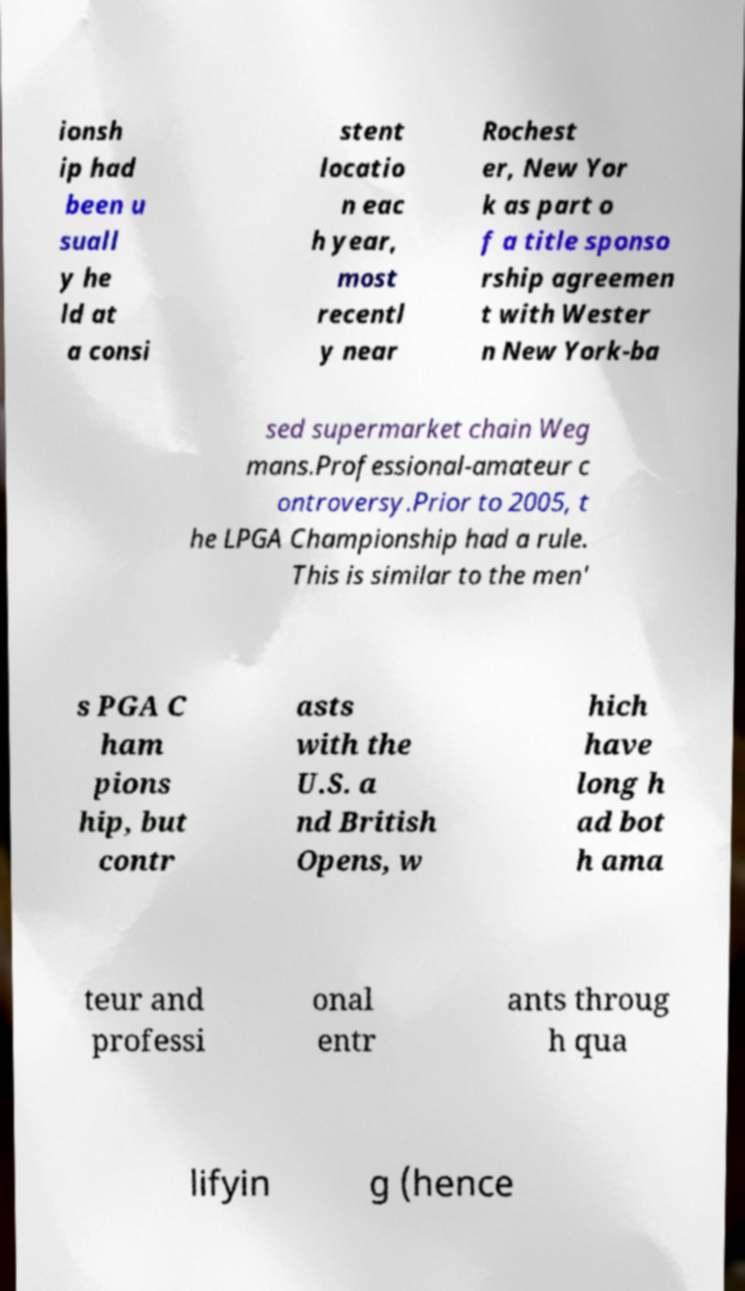Can you read and provide the text displayed in the image?This photo seems to have some interesting text. Can you extract and type it out for me? ionsh ip had been u suall y he ld at a consi stent locatio n eac h year, most recentl y near Rochest er, New Yor k as part o f a title sponso rship agreemen t with Wester n New York-ba sed supermarket chain Weg mans.Professional-amateur c ontroversy.Prior to 2005, t he LPGA Championship had a rule. This is similar to the men' s PGA C ham pions hip, but contr asts with the U.S. a nd British Opens, w hich have long h ad bot h ama teur and professi onal entr ants throug h qua lifyin g (hence 